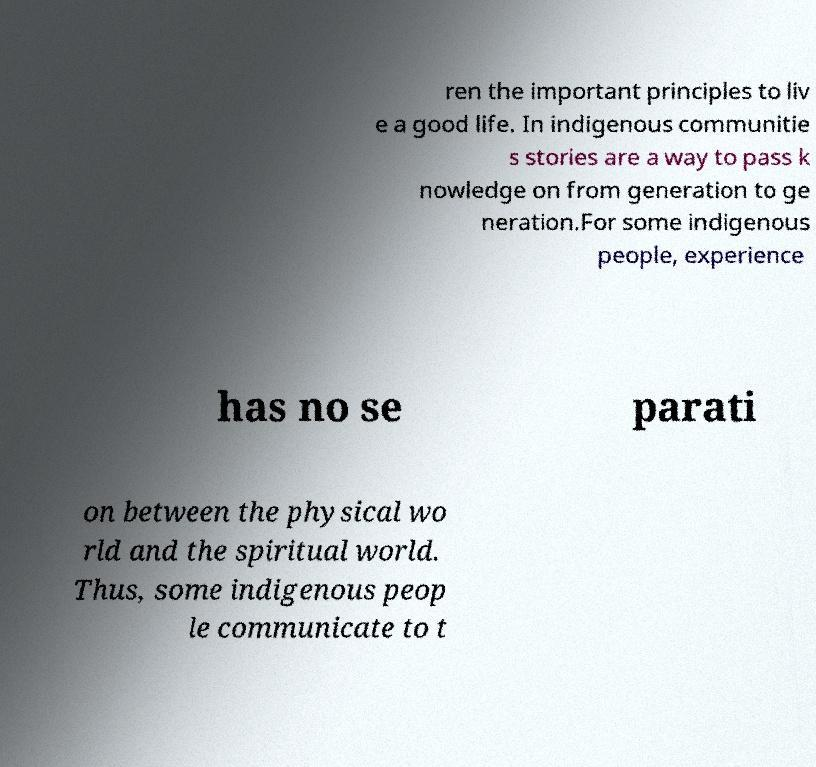Please read and relay the text visible in this image. What does it say? ren the important principles to liv e a good life. In indigenous communitie s stories are a way to pass k nowledge on from generation to ge neration.For some indigenous people, experience has no se parati on between the physical wo rld and the spiritual world. Thus, some indigenous peop le communicate to t 